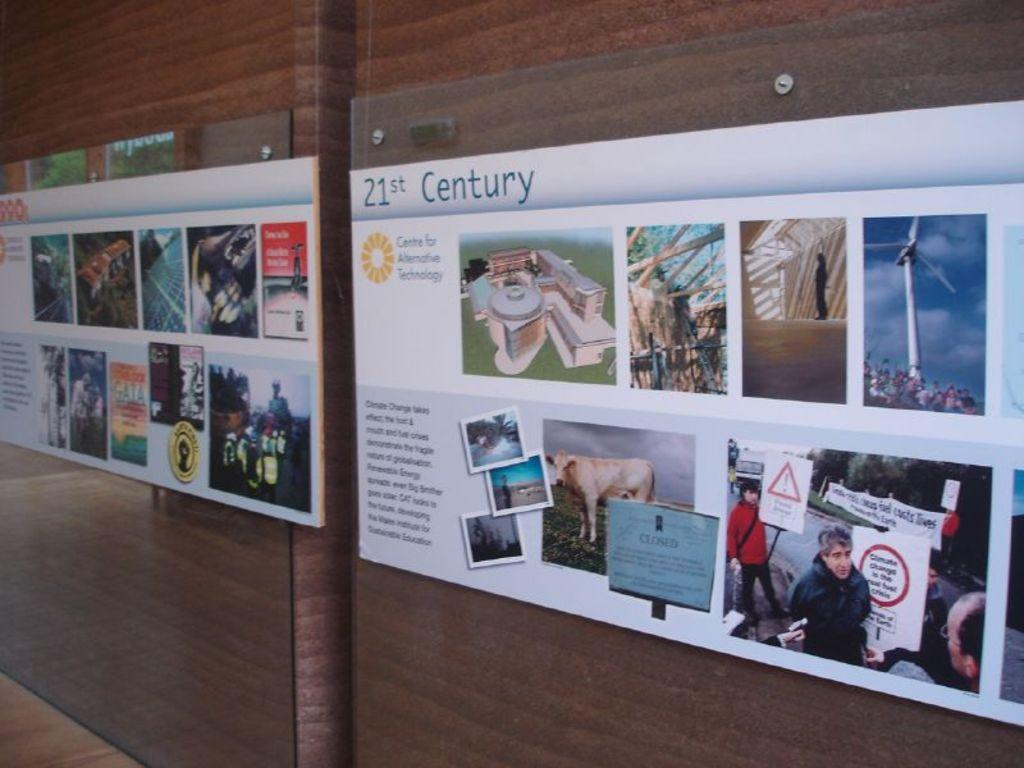<image>
Offer a succinct explanation of the picture presented. a poster for the 21st century hangs on a wooden wall 